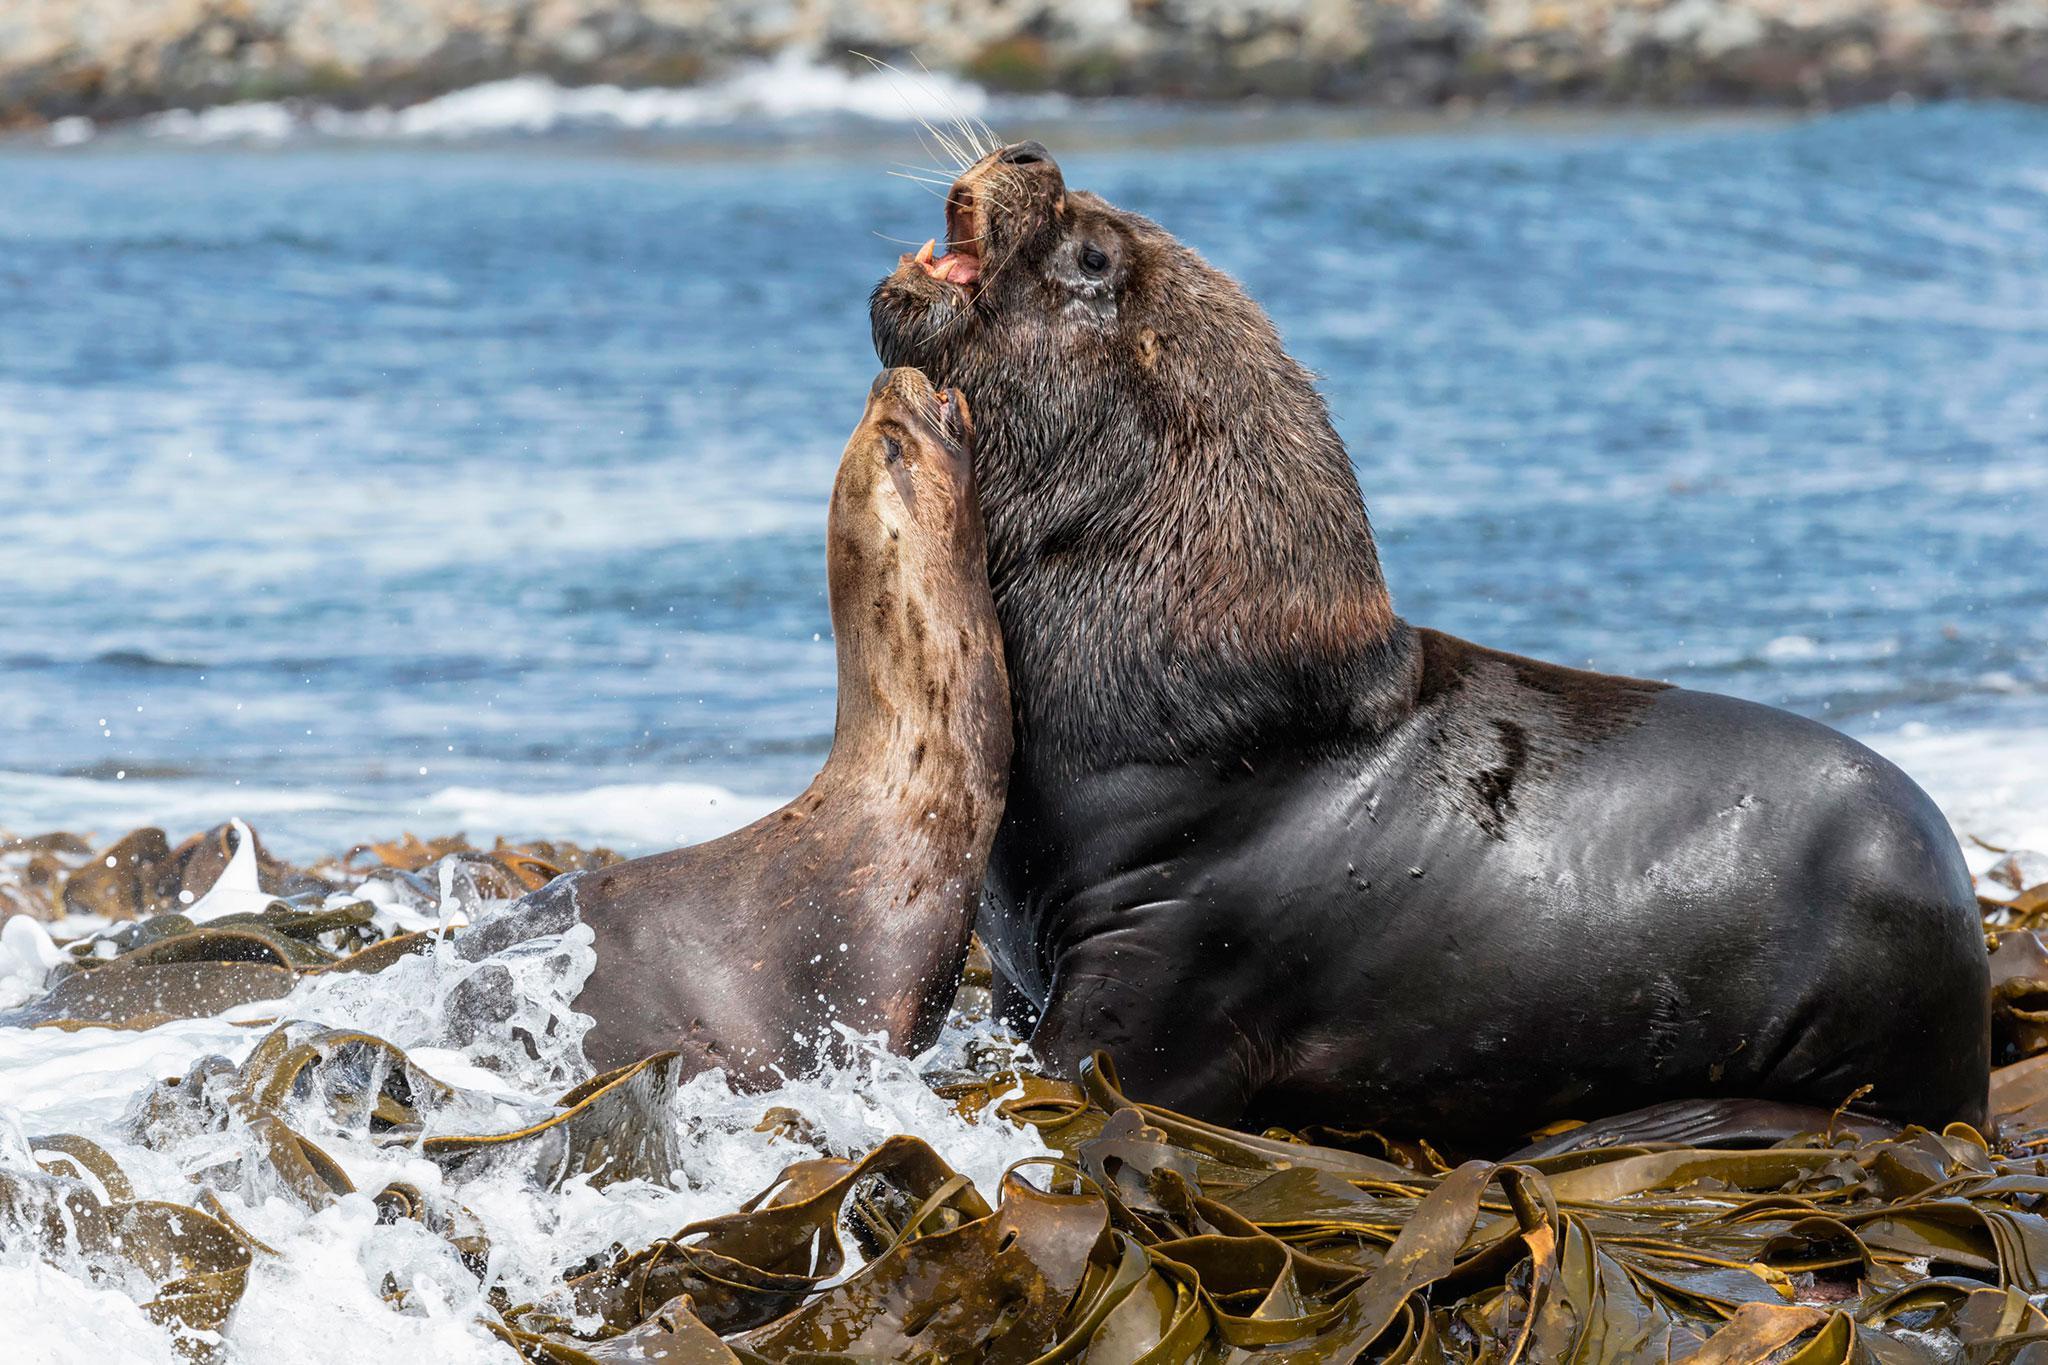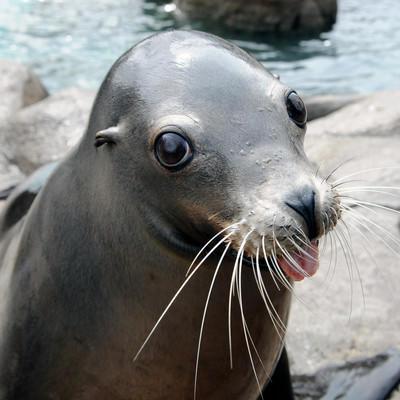The first image is the image on the left, the second image is the image on the right. Considering the images on both sides, is "Three animals are near the water." valid? Answer yes or no. Yes. The first image is the image on the left, the second image is the image on the right. Considering the images on both sides, is "At least one image shows a seal on the edge of a man-made pool." valid? Answer yes or no. No. 